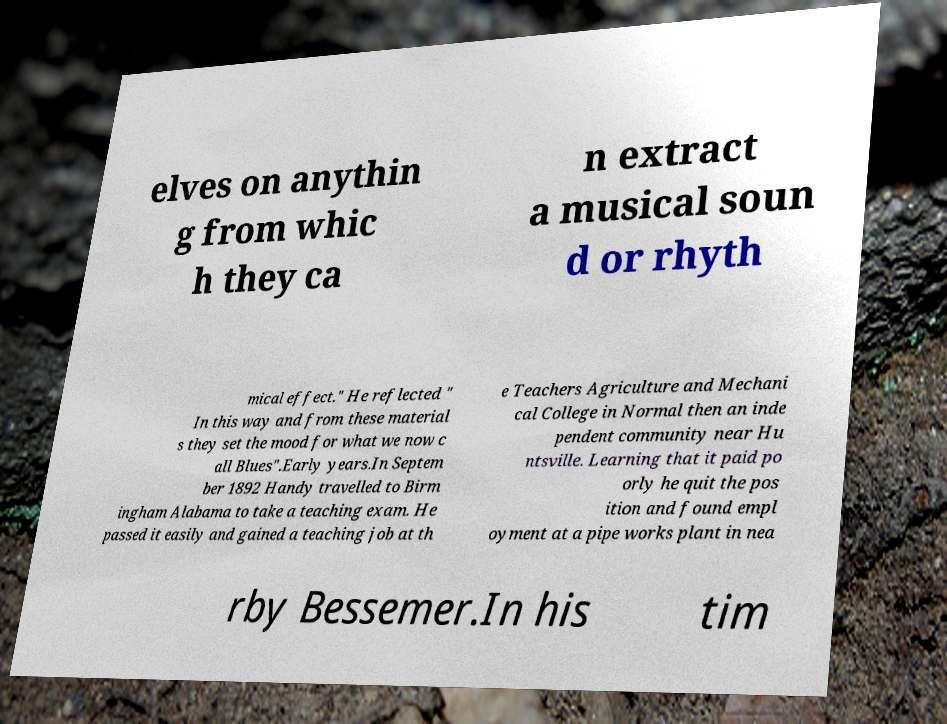Can you read and provide the text displayed in the image?This photo seems to have some interesting text. Can you extract and type it out for me? elves on anythin g from whic h they ca n extract a musical soun d or rhyth mical effect." He reflected " In this way and from these material s they set the mood for what we now c all Blues".Early years.In Septem ber 1892 Handy travelled to Birm ingham Alabama to take a teaching exam. He passed it easily and gained a teaching job at th e Teachers Agriculture and Mechani cal College in Normal then an inde pendent community near Hu ntsville. Learning that it paid po orly he quit the pos ition and found empl oyment at a pipe works plant in nea rby Bessemer.In his tim 